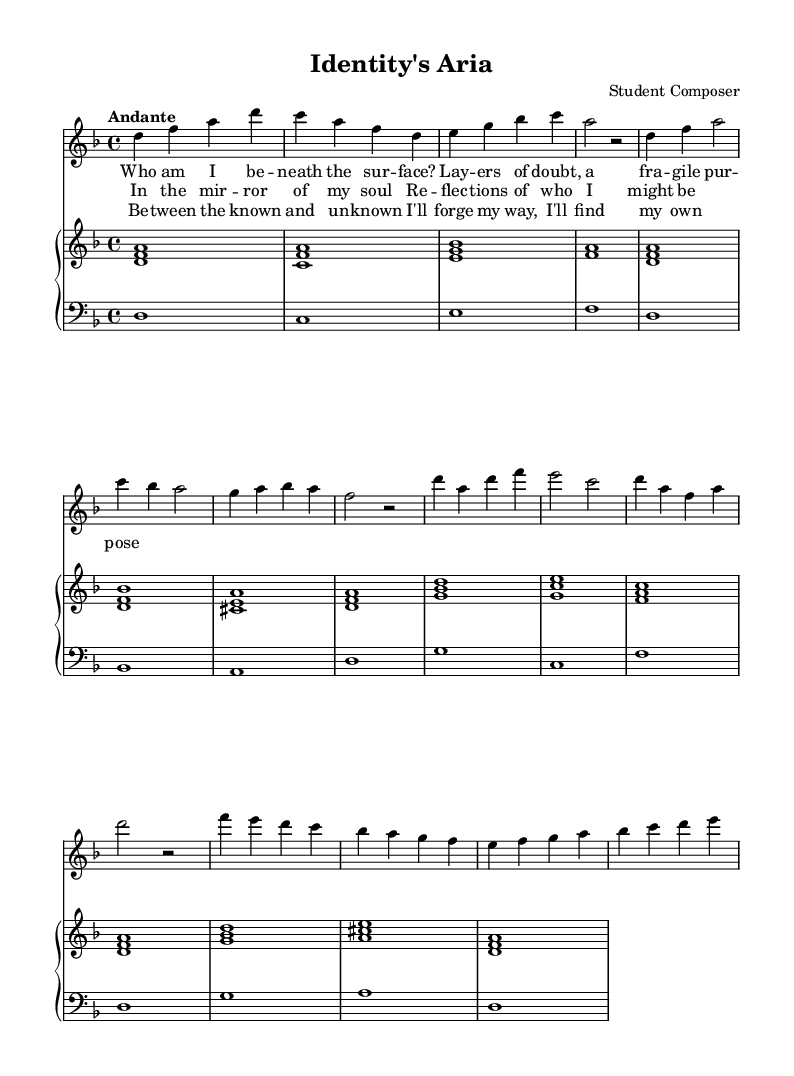What is the key signature of this music? The key signature is indicated by the "key d minor" at the beginning of the score. D minor has one flat, marking F natural as the lowered seventh degree.
Answer: d minor What is the time signature of this music? The time signature is shown as "4/4" after the key signature. This means there are four beats per measure, and the quarter note gets one beat.
Answer: 4/4 What is the tempo marking for this piece? The tempo marking is "Andante," which is found near the beginning of the score, specifying the speed of the piece. Andante indicates a moderately slow pace.
Answer: Andante How many verses are in the soprano part? There are three distinct sections in the soprano part: an introduction, verse one, the chorus, and a bridge, hence totaling three verses. Each section can be distinguished by lyric lines.
Answer: Three What is the main theme reflected in the lyrics of this opera? The lyrics speak about identity and self-discovery, focusing on questions of self-awareness and personal growth as encapsulated in the phrases like “Who am I be--neath the sur--face?” and “Re--flec--tions of who I might be.”
Answer: Identity Which musical section begins with "In the mirror of my soul"? This line marks the beginning of the chorus section, which is primarily concerned with the reflections of personal identity and self-perception. The layout shows that this section follows the first verse.
Answer: Chorus How does the bridge section contribute to the themes of the opera? The bridge emphasizes the journey between the known and unknown, highlighting the struggle and determination involved in finding one’s path, as expressed in “I'll forge my way, I'll find my own.” This deepens the narrative of self-discovery present throughout the opera.
Answer: The bridge 